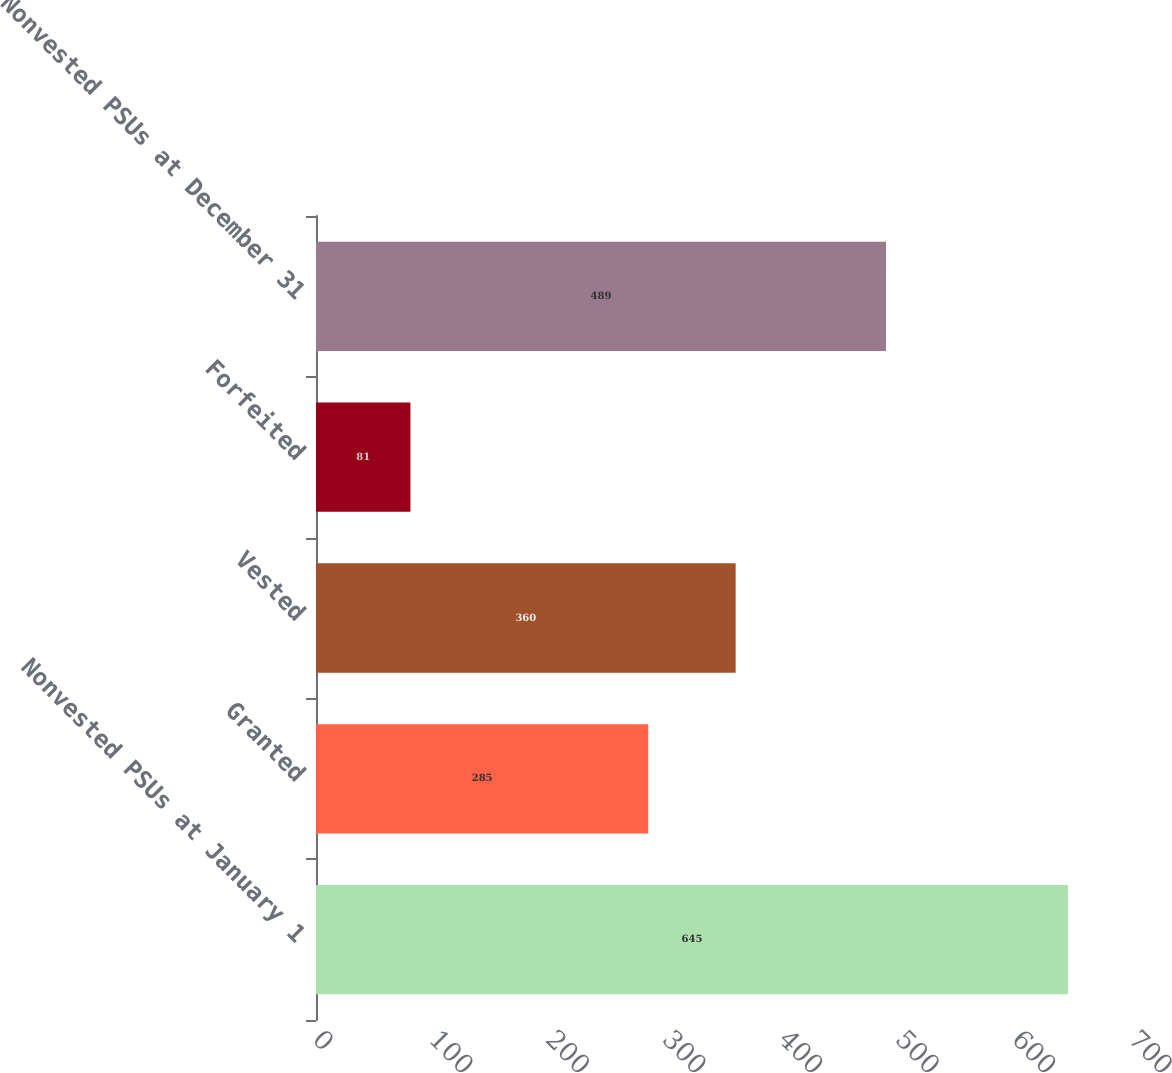<chart> <loc_0><loc_0><loc_500><loc_500><bar_chart><fcel>Nonvested PSUs at January 1<fcel>Granted<fcel>Vested<fcel>Forfeited<fcel>Nonvested PSUs at December 31<nl><fcel>645<fcel>285<fcel>360<fcel>81<fcel>489<nl></chart> 